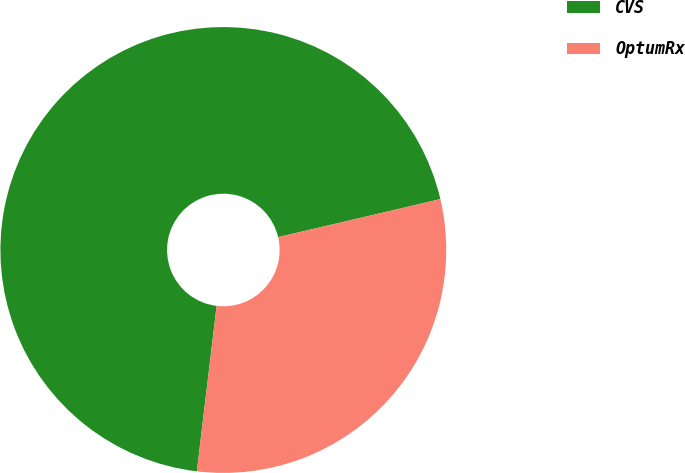Convert chart to OTSL. <chart><loc_0><loc_0><loc_500><loc_500><pie_chart><fcel>CVS<fcel>OptumRx<nl><fcel>69.44%<fcel>30.56%<nl></chart> 